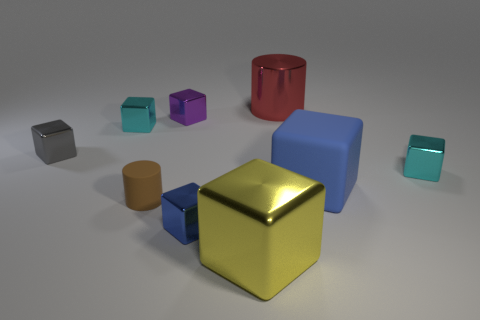Subtract all purple blocks. How many blocks are left? 6 Subtract all matte cubes. How many cubes are left? 6 Subtract all yellow cubes. Subtract all yellow cylinders. How many cubes are left? 6 Add 1 red rubber objects. How many objects exist? 10 Subtract all cylinders. How many objects are left? 7 Add 1 tiny brown cylinders. How many tiny brown cylinders exist? 2 Subtract 0 gray cylinders. How many objects are left? 9 Subtract all big purple shiny spheres. Subtract all small cylinders. How many objects are left? 8 Add 4 large shiny cylinders. How many large shiny cylinders are left? 5 